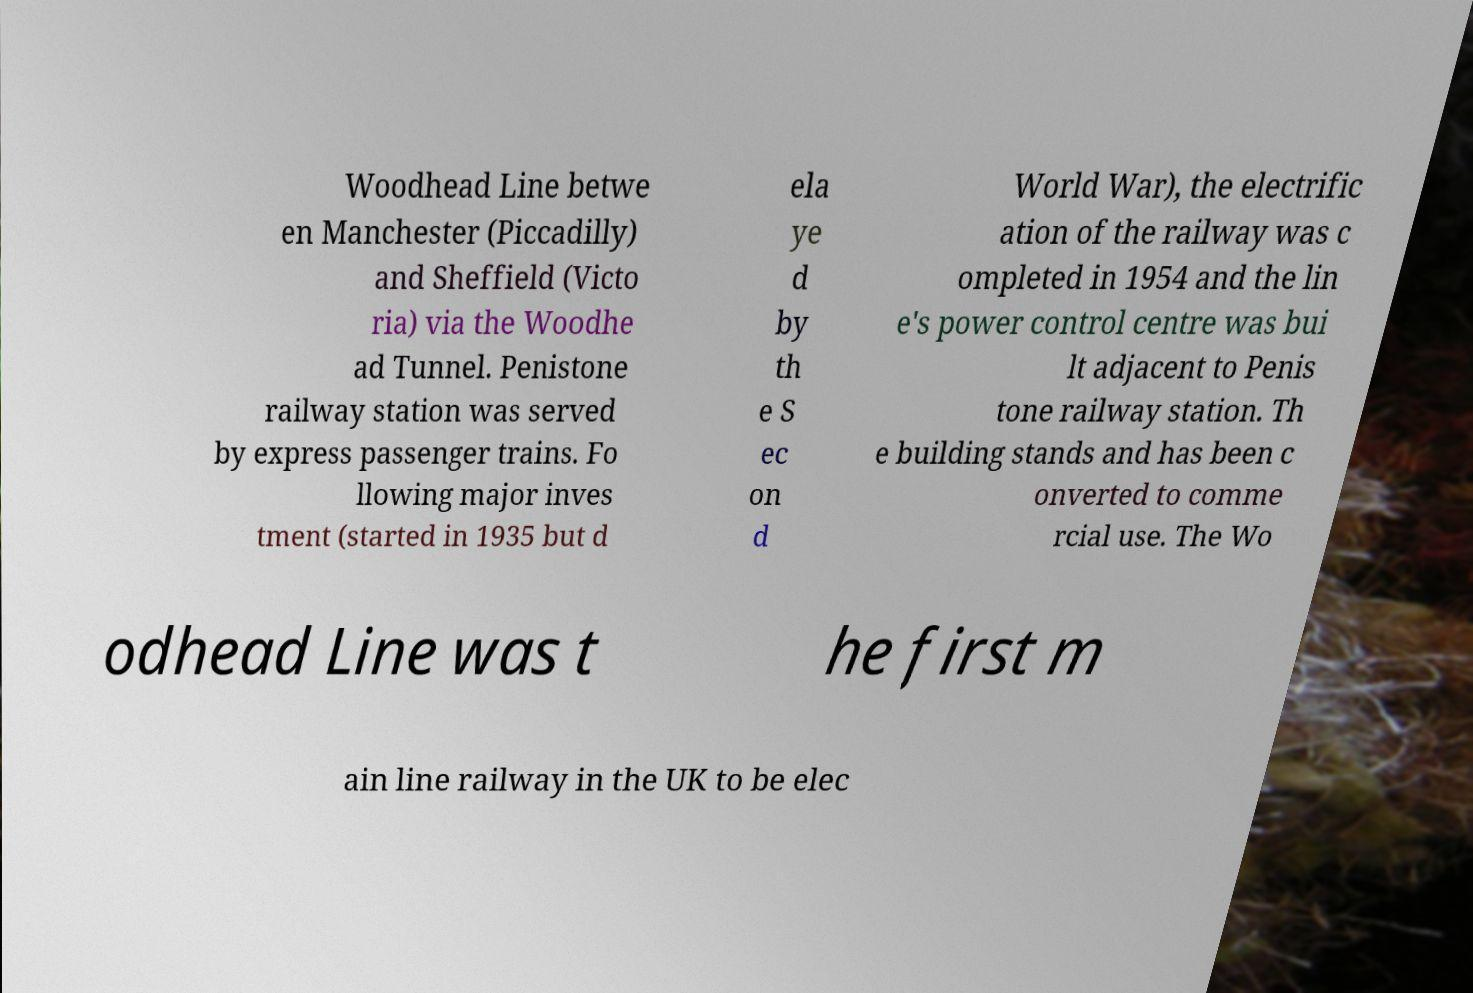I need the written content from this picture converted into text. Can you do that? Woodhead Line betwe en Manchester (Piccadilly) and Sheffield (Victo ria) via the Woodhe ad Tunnel. Penistone railway station was served by express passenger trains. Fo llowing major inves tment (started in 1935 but d ela ye d by th e S ec on d World War), the electrific ation of the railway was c ompleted in 1954 and the lin e's power control centre was bui lt adjacent to Penis tone railway station. Th e building stands and has been c onverted to comme rcial use. The Wo odhead Line was t he first m ain line railway in the UK to be elec 